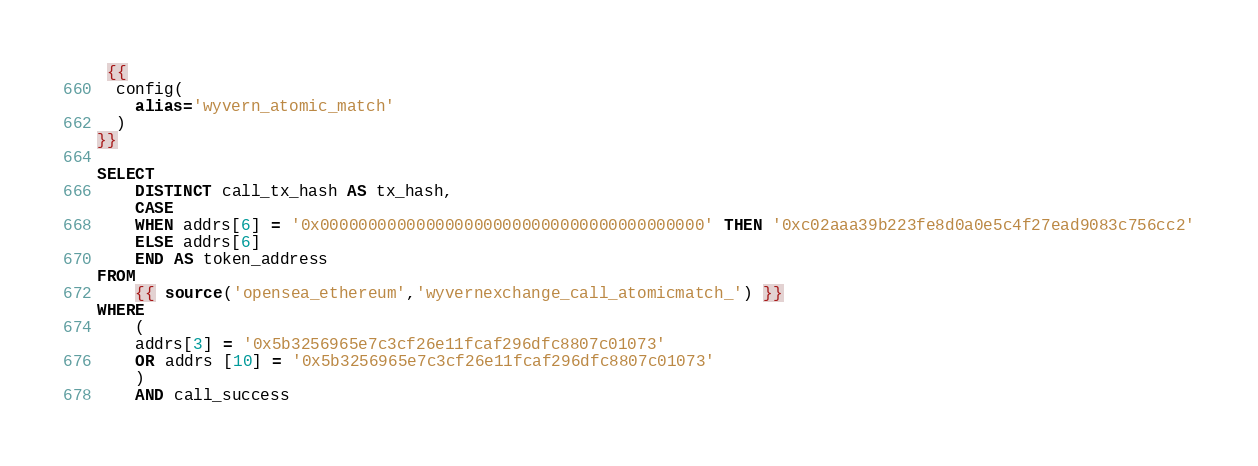Convert code to text. <code><loc_0><loc_0><loc_500><loc_500><_SQL_> {{
  config(
    alias='wyvern_atomic_match'
  )
}}

SELECT
    DISTINCT call_tx_hash AS tx_hash,
    CASE
    WHEN addrs[6] = '0x0000000000000000000000000000000000000000' THEN '0xc02aaa39b223fe8d0a0e5c4f27ead9083c756cc2'
    ELSE addrs[6]
    END AS token_address
FROM
    {{ source('opensea_ethereum','wyvernexchange_call_atomicmatch_') }}
WHERE
    (
    addrs[3] = '0x5b3256965e7c3cf26e11fcaf296dfc8807c01073'
    OR addrs [10] = '0x5b3256965e7c3cf26e11fcaf296dfc8807c01073'
    )
    AND call_success

</code> 